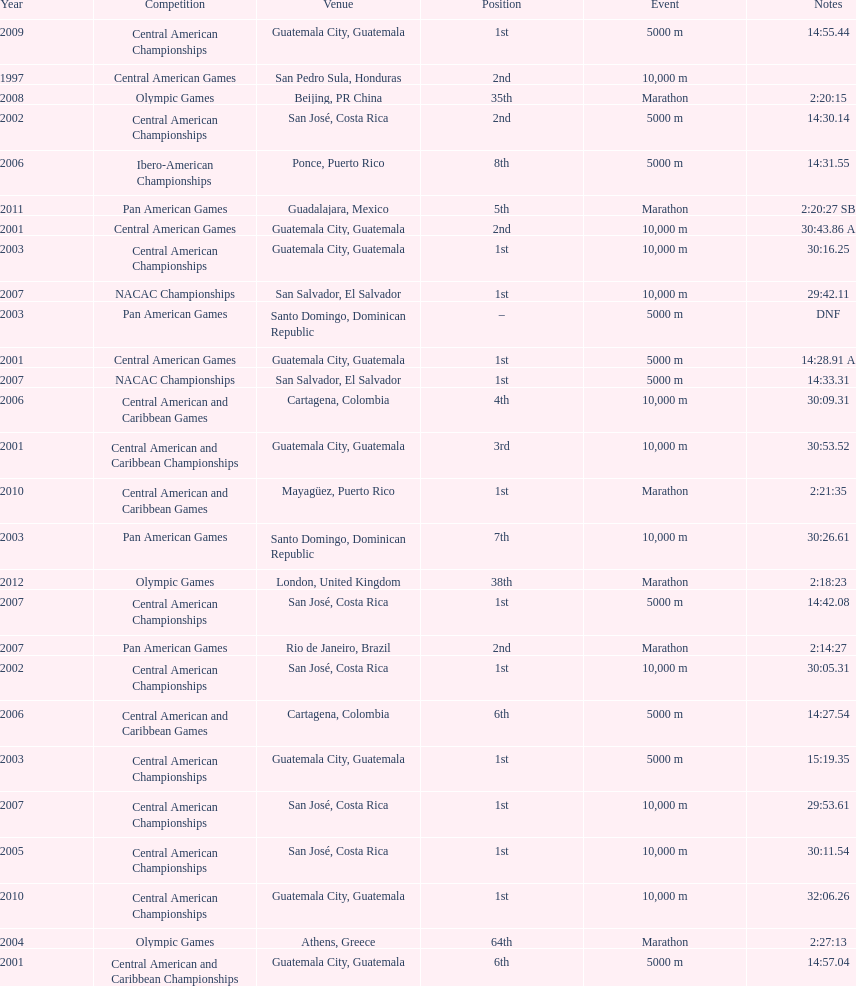Where was the only 64th position held? Athens, Greece. 